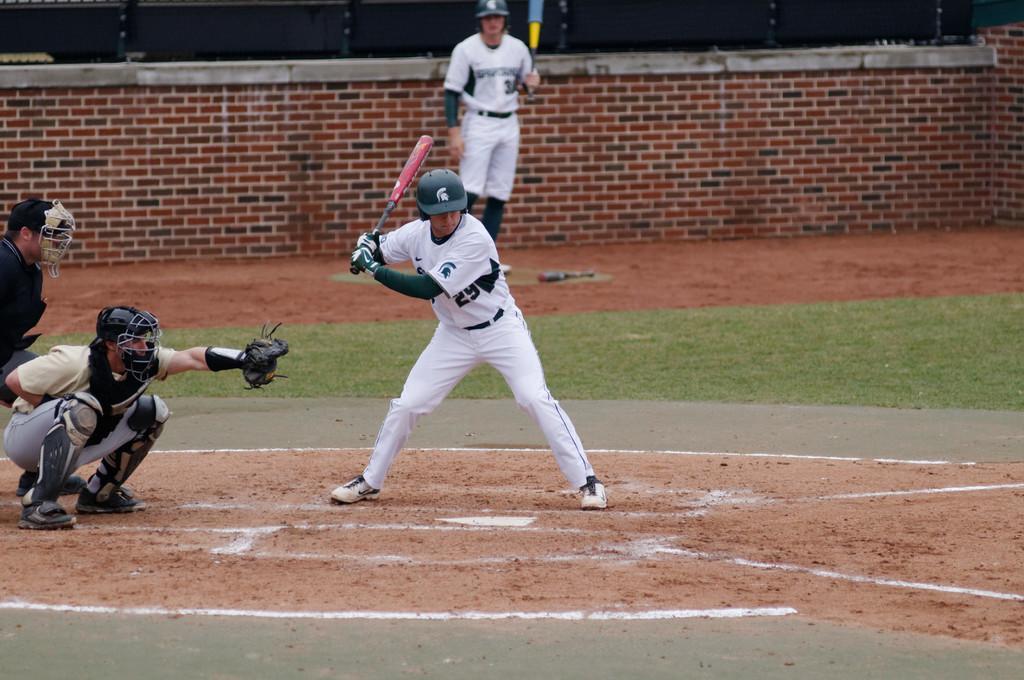In one or two sentences, can you explain what this image depicts? In this image we can see a few people playing baseball, two of them holding bats, also we can see the grass, and the wall. 